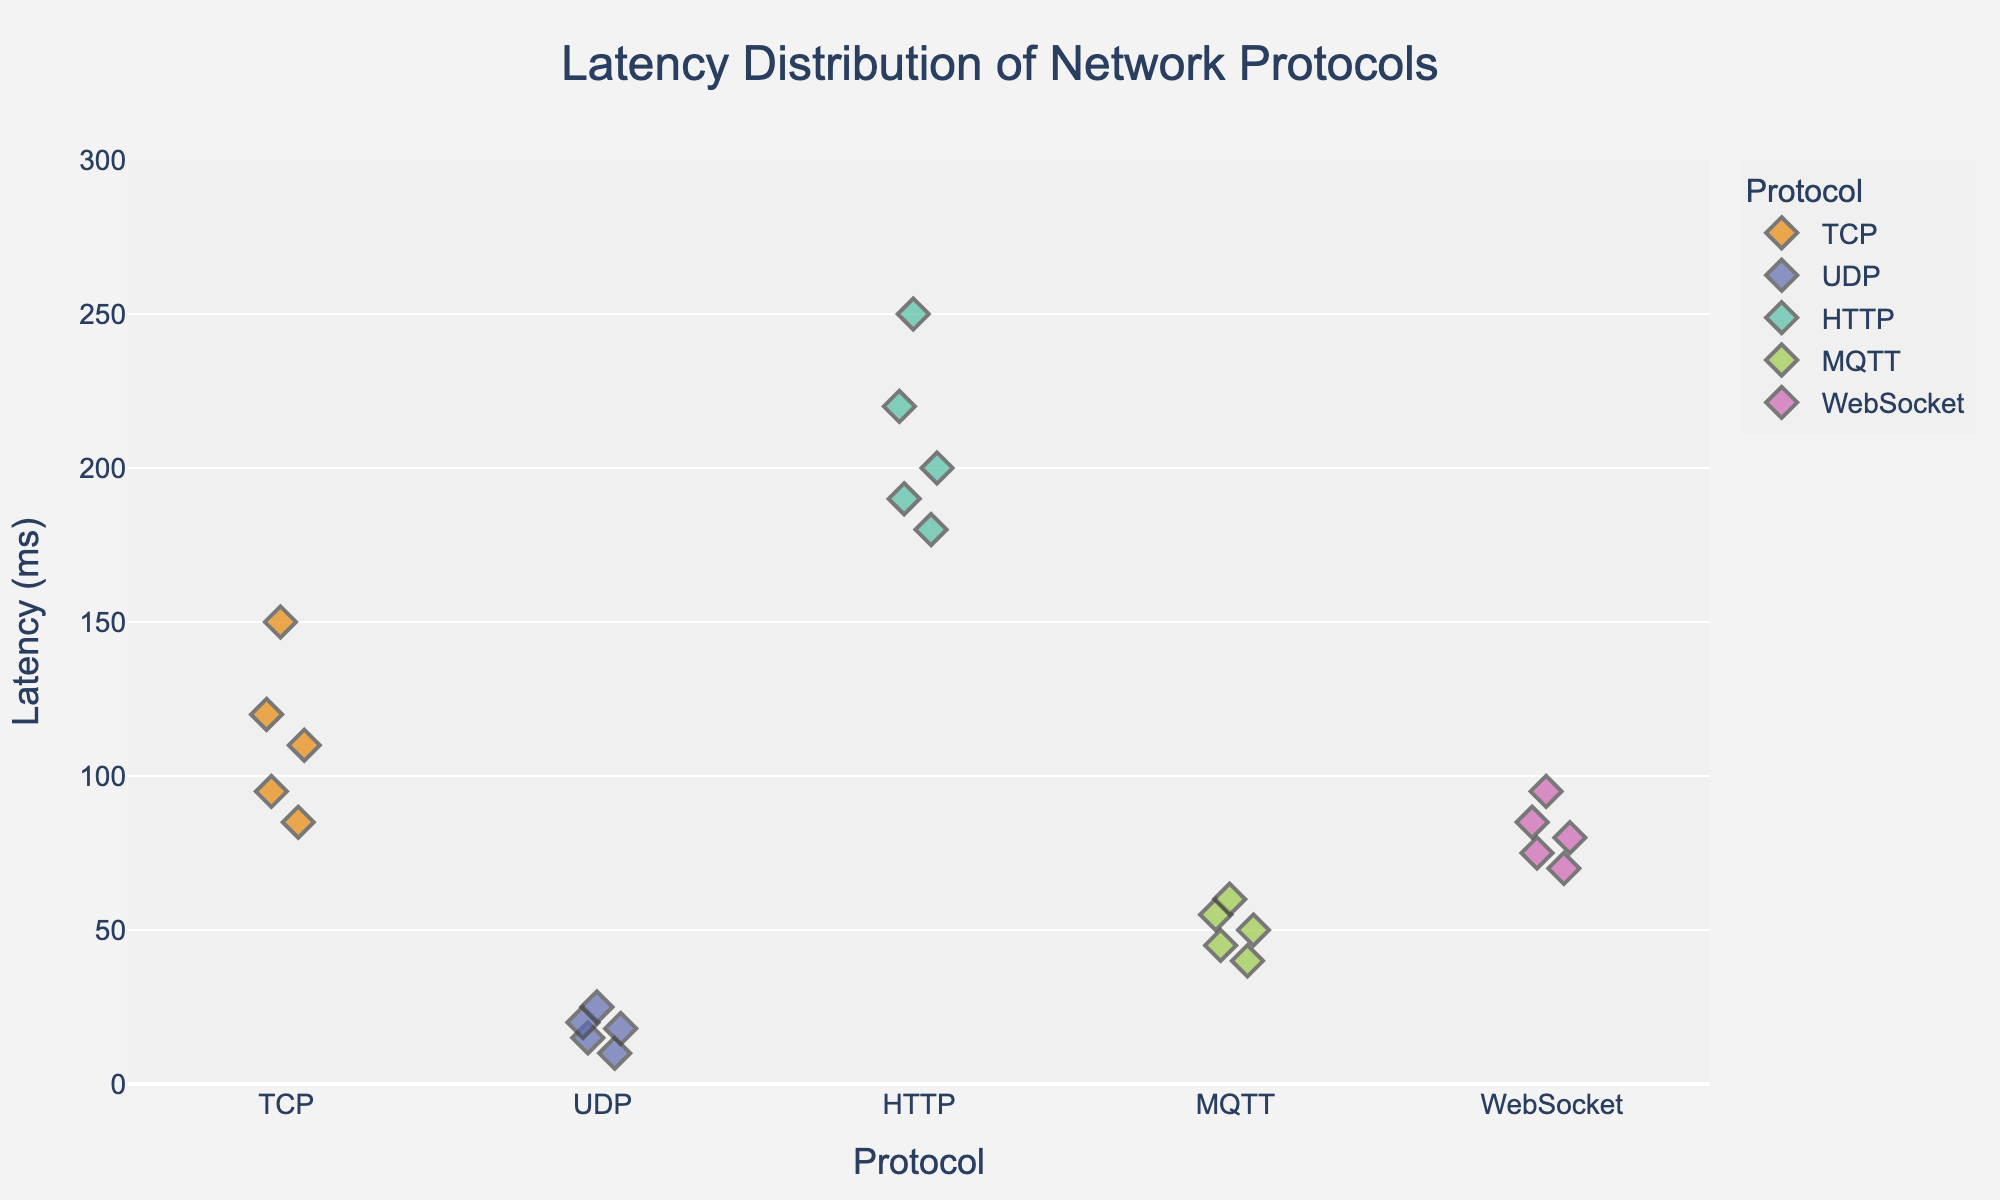Which protocol has the lowest latency? From the visual inspection, UDP data points are clustered at the lowest y-values, ranging from 10 to 25 ms. Therefore, UDP has the lowest latency.
Answer: UDP Which protocol has the highest latency? HTTP data points are clustered at the highest y-values, ranging from 180 to 250 ms. Therefore, HTTP has the highest latency.
Answer: HTTP How many data points are there for the MQTT protocol? Each diamond-shaped marker represents a data point. By counting the markers for the MQTT protocol, you can see there are 5 data points.
Answer: 5 Which protocol shows the most variability in latency? Variability can be observed by the spread of data points. HTTP has the widest range from 180 to 250 ms, indicating the most variability.
Answer: HTTP Compare the average latency for TCP and WebSocket. Which one has a lower average latency? Calculate the average by summing the latencies for TCP (120 + 85 + 150 + 95 + 110 = 560 ms) and WebSocket (80 + 70 + 95 + 75 + 85 = 405 ms), then divide by their respective counts (5). TCP: 560/5 = 112 ms, WebSocket: 405/5 = 81 ms. Therefore, WebSocket has a lower average latency.
Answer: WebSocket What is the y-axis title in the figure? The title of the y-axis is clearly labeled as "Latency (ms)" which indicates the unit of measurement for latency is in milliseconds.
Answer: Latency (ms) Which protocol has the median latency of 85 ms? By arranging the data points for TCP (85, 95, 110, 120, 150), the median falls in the middle value which is 110 ms, so it's not TCP. For WebSocket (70, 75, 80, 85, 95), the median falls in the middle value which is 80 ms, so it's not WebSocket. Therefore, none of the protocols have a median latency of 85 ms.
Answer: None Is there any protocol whose all data points are below 50 ms? Checking the scatter points visually for all protocols, UDP (10, 15, 18, 20, 25 ms) is the only one with all points below 50 ms.
Answer: UDP How does the distribution of latencies for UDP compare to the distribution for TCP? UDP latencies are tightly clustered between 10 and 25 ms, while TCP latencies have a broader distribution ranging from 85 to 150 ms. This shows that UDP has a more consistent latency while TCP's latency varies more.
Answer: UDP has a more consistent latency and lower values compared to TCP 